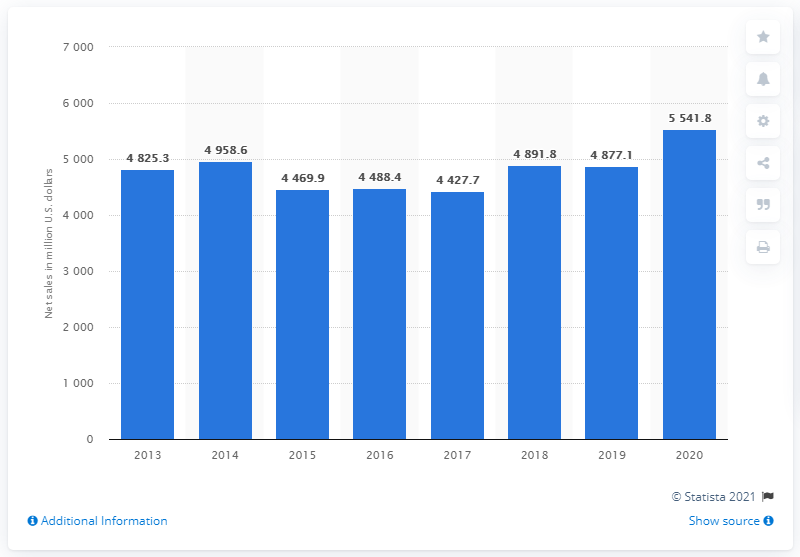Identify some key points in this picture. In 2020, Herbalife's global net sales amounted to $55,418,000 in dollars. 